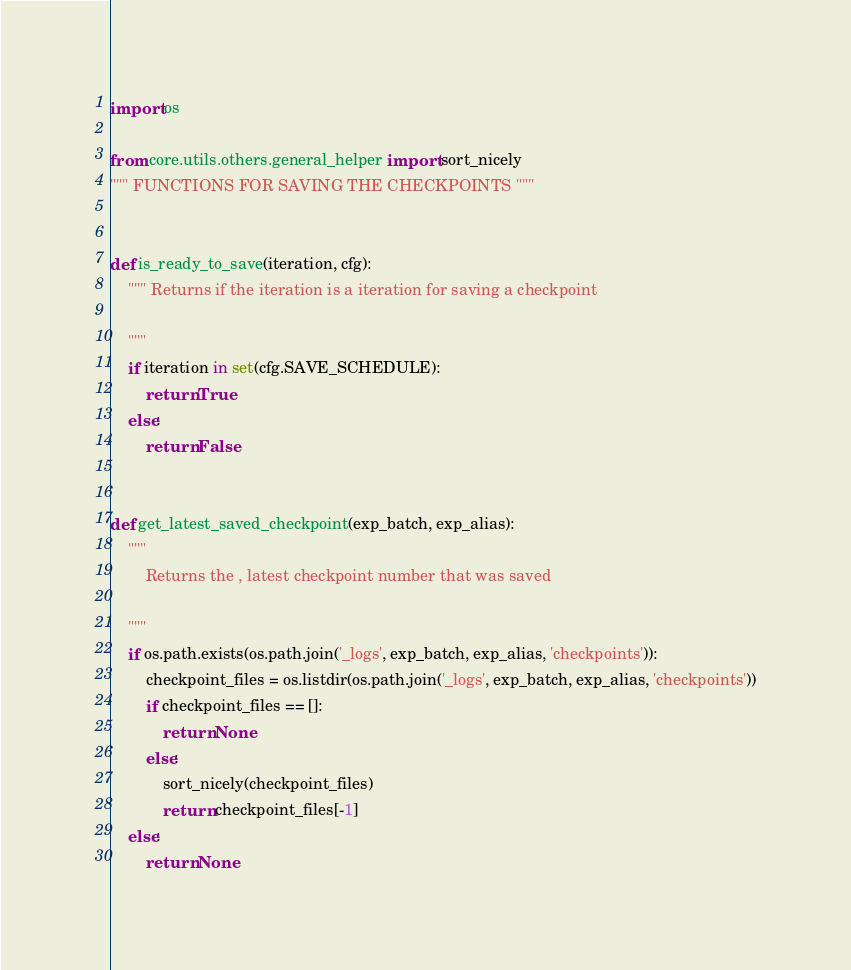<code> <loc_0><loc_0><loc_500><loc_500><_Python_>import os

from core.utils.others.general_helper import sort_nicely
""" FUNCTIONS FOR SAVING THE CHECKPOINTS """


def is_ready_to_save(iteration, cfg):
    """ Returns if the iteration is a iteration for saving a checkpoint

    """
    if iteration in set(cfg.SAVE_SCHEDULE):
        return True
    else:
        return False


def get_latest_saved_checkpoint(exp_batch, exp_alias):
    """
        Returns the , latest checkpoint number that was saved

    """
    if os.path.exists(os.path.join('_logs', exp_batch, exp_alias, 'checkpoints')):
        checkpoint_files = os.listdir(os.path.join('_logs', exp_batch, exp_alias, 'checkpoints'))
        if checkpoint_files == []:
            return None
        else:
            sort_nicely(checkpoint_files)
            return checkpoint_files[-1]
    else:
        return None
</code> 